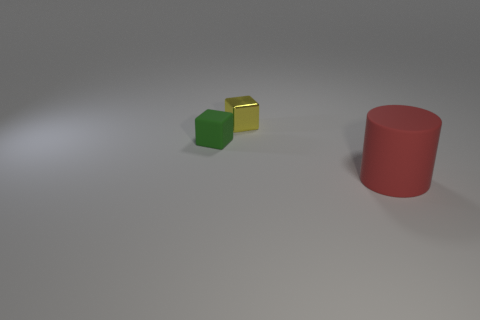What number of objects are either tiny gray spheres or small blocks behind the small green block?
Offer a terse response. 1. What material is the green object that is the same size as the metallic cube?
Make the answer very short. Rubber. Do the yellow block and the red cylinder have the same material?
Keep it short and to the point. No. What is the color of the object that is in front of the metallic object and right of the green matte thing?
Offer a very short reply. Red. There is a green rubber object that is the same size as the yellow metallic cube; what shape is it?
Keep it short and to the point. Cube. What number of other objects are there of the same material as the large cylinder?
Ensure brevity in your answer.  1. There is a yellow shiny object; is it the same size as the matte object that is behind the red matte object?
Give a very brief answer. Yes. What is the color of the matte cylinder?
Ensure brevity in your answer.  Red. There is a small thing that is right of the matte object that is behind the thing on the right side of the metallic thing; what shape is it?
Give a very brief answer. Cube. What is the material of the small object that is behind the small object that is to the left of the small shiny block?
Offer a terse response. Metal. 